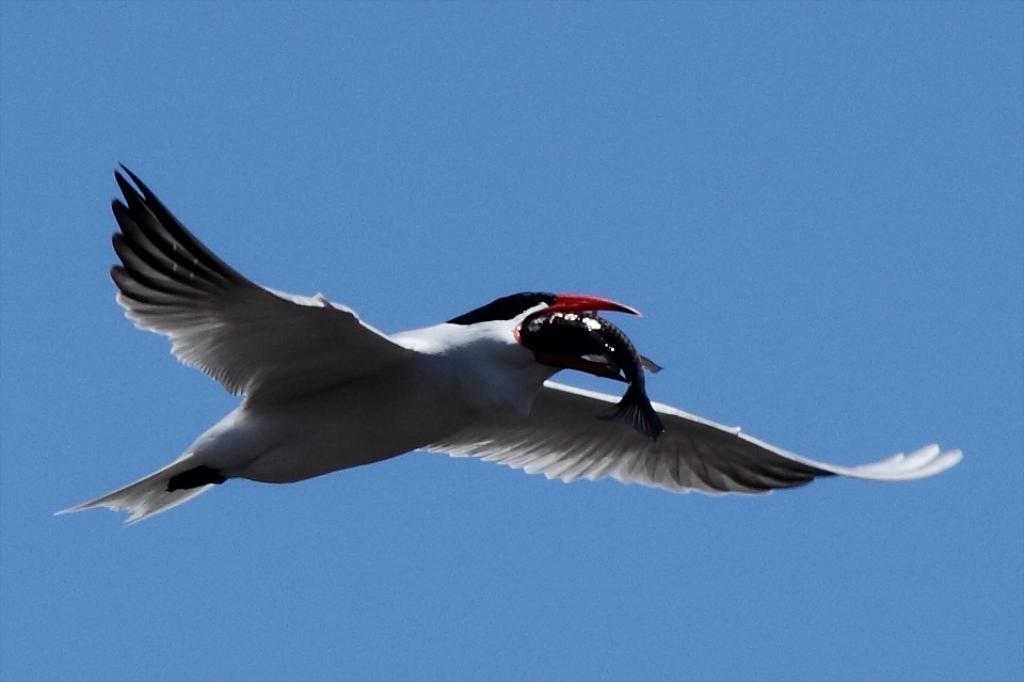Describe this image in one or two sentences. In this picture I can observe a bird flying in the air. The bird is in white and black color. I can observe a fish in the mouth of the bird. In the background there is a sky. 